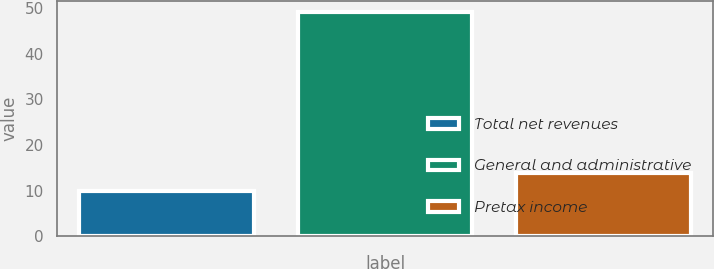Convert chart. <chart><loc_0><loc_0><loc_500><loc_500><bar_chart><fcel>Total net revenues<fcel>General and administrative<fcel>Pretax income<nl><fcel>10<fcel>49<fcel>13.9<nl></chart> 